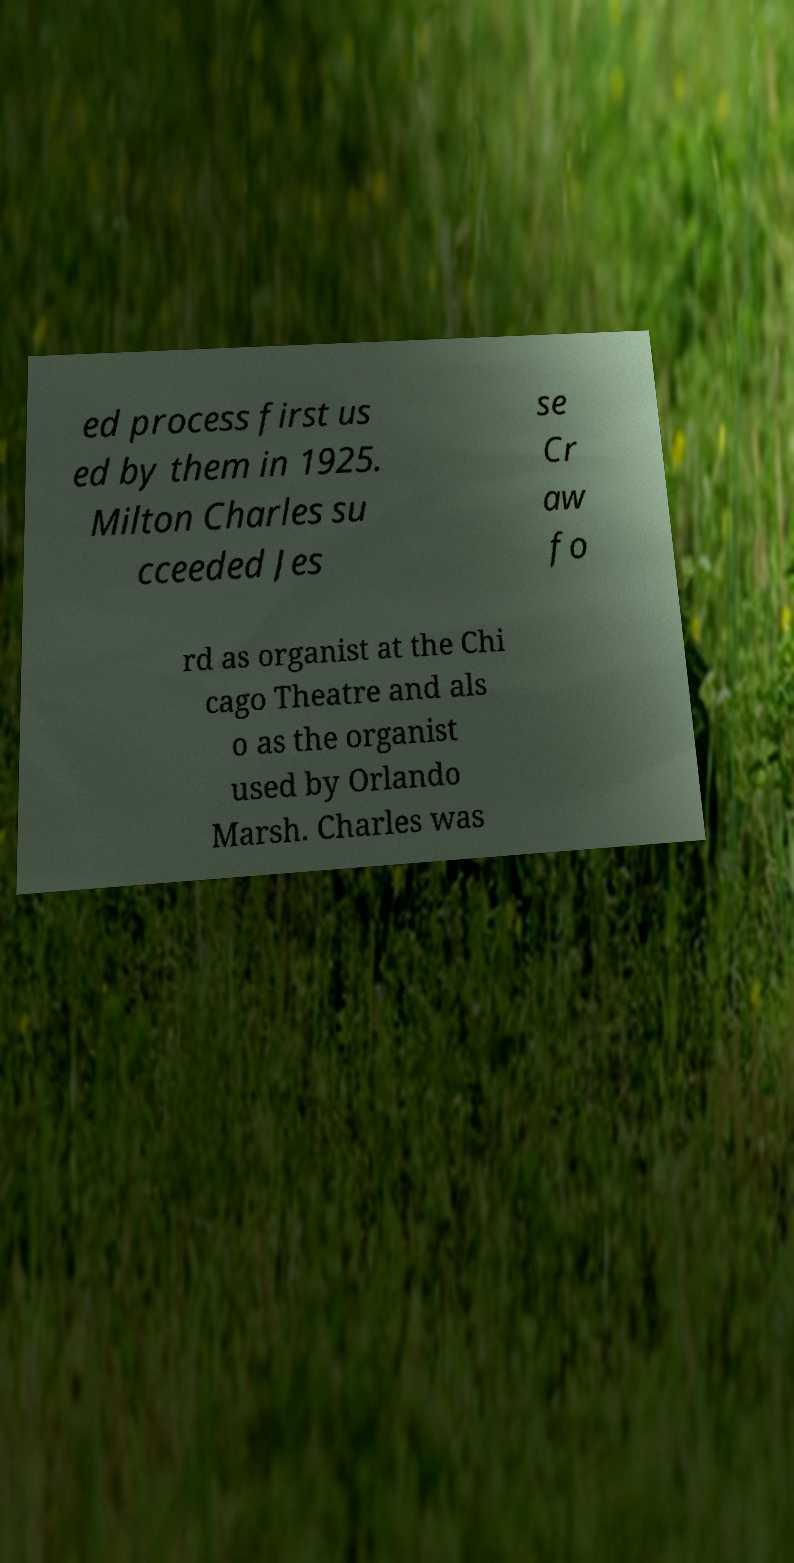Can you accurately transcribe the text from the provided image for me? ed process first us ed by them in 1925. Milton Charles su cceeded Jes se Cr aw fo rd as organist at the Chi cago Theatre and als o as the organist used by Orlando Marsh. Charles was 